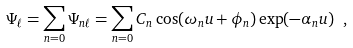Convert formula to latex. <formula><loc_0><loc_0><loc_500><loc_500>\Psi _ { \ell } = \sum _ { n = 0 } \Psi _ { n \ell } = \sum _ { n = 0 } C _ { n } \cos ( \omega _ { n } u + \phi _ { n } ) \exp ( - \alpha _ { n } u ) \ ,</formula> 